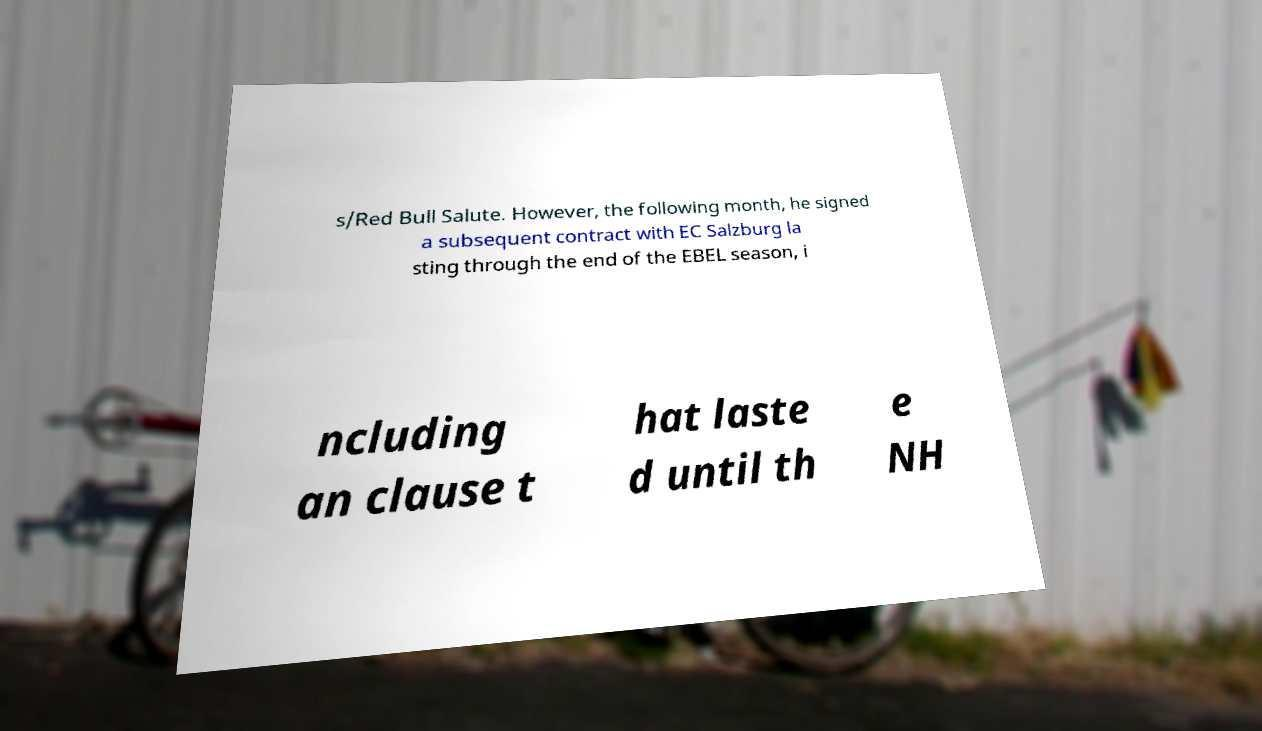Can you accurately transcribe the text from the provided image for me? s/Red Bull Salute. However, the following month, he signed a subsequent contract with EC Salzburg la sting through the end of the EBEL season, i ncluding an clause t hat laste d until th e NH 